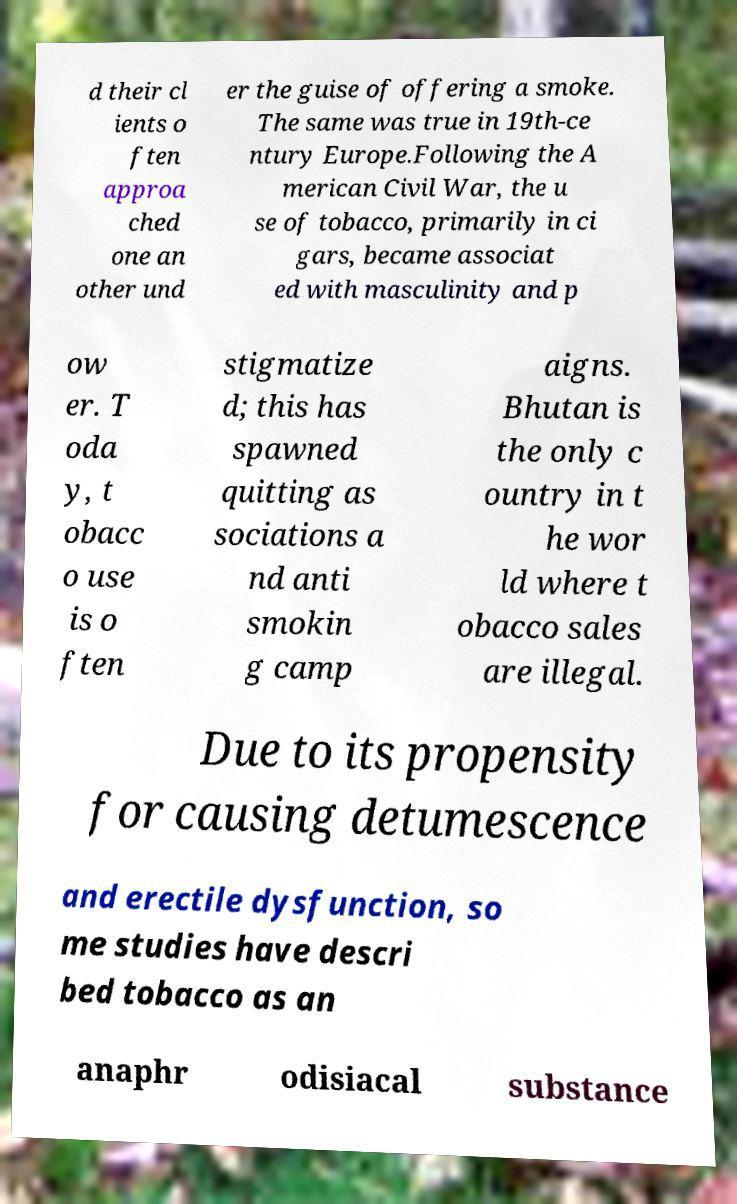What messages or text are displayed in this image? I need them in a readable, typed format. d their cl ients o ften approa ched one an other und er the guise of offering a smoke. The same was true in 19th-ce ntury Europe.Following the A merican Civil War, the u se of tobacco, primarily in ci gars, became associat ed with masculinity and p ow er. T oda y, t obacc o use is o ften stigmatize d; this has spawned quitting as sociations a nd anti smokin g camp aigns. Bhutan is the only c ountry in t he wor ld where t obacco sales are illegal. Due to its propensity for causing detumescence and erectile dysfunction, so me studies have descri bed tobacco as an anaphr odisiacal substance 